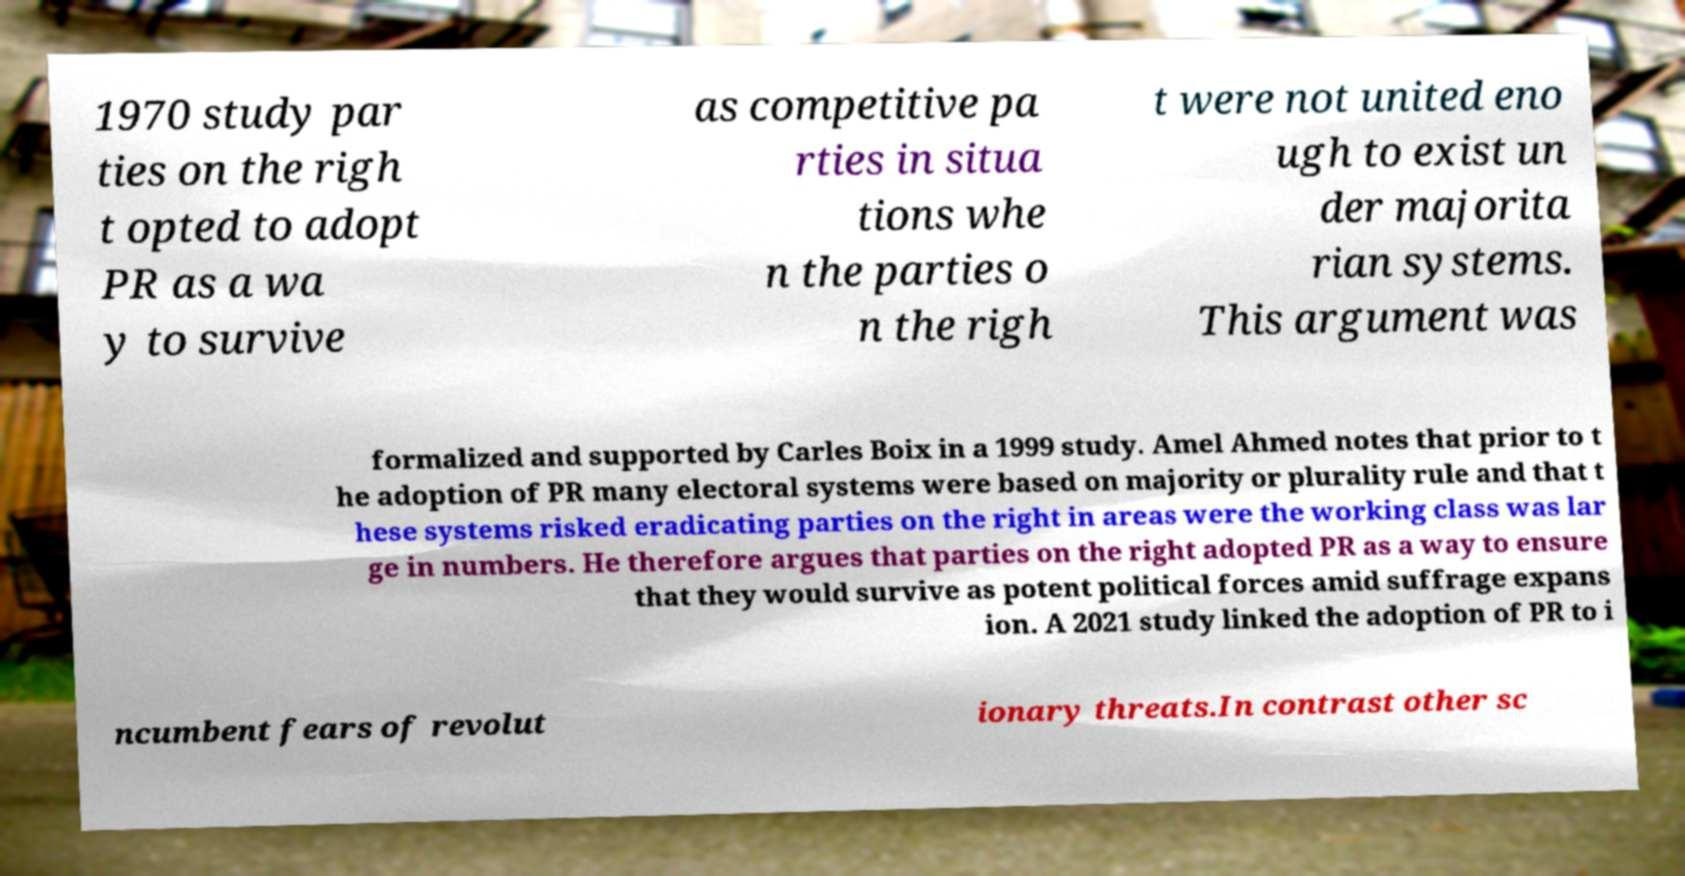There's text embedded in this image that I need extracted. Can you transcribe it verbatim? 1970 study par ties on the righ t opted to adopt PR as a wa y to survive as competitive pa rties in situa tions whe n the parties o n the righ t were not united eno ugh to exist un der majorita rian systems. This argument was formalized and supported by Carles Boix in a 1999 study. Amel Ahmed notes that prior to t he adoption of PR many electoral systems were based on majority or plurality rule and that t hese systems risked eradicating parties on the right in areas were the working class was lar ge in numbers. He therefore argues that parties on the right adopted PR as a way to ensure that they would survive as potent political forces amid suffrage expans ion. A 2021 study linked the adoption of PR to i ncumbent fears of revolut ionary threats.In contrast other sc 